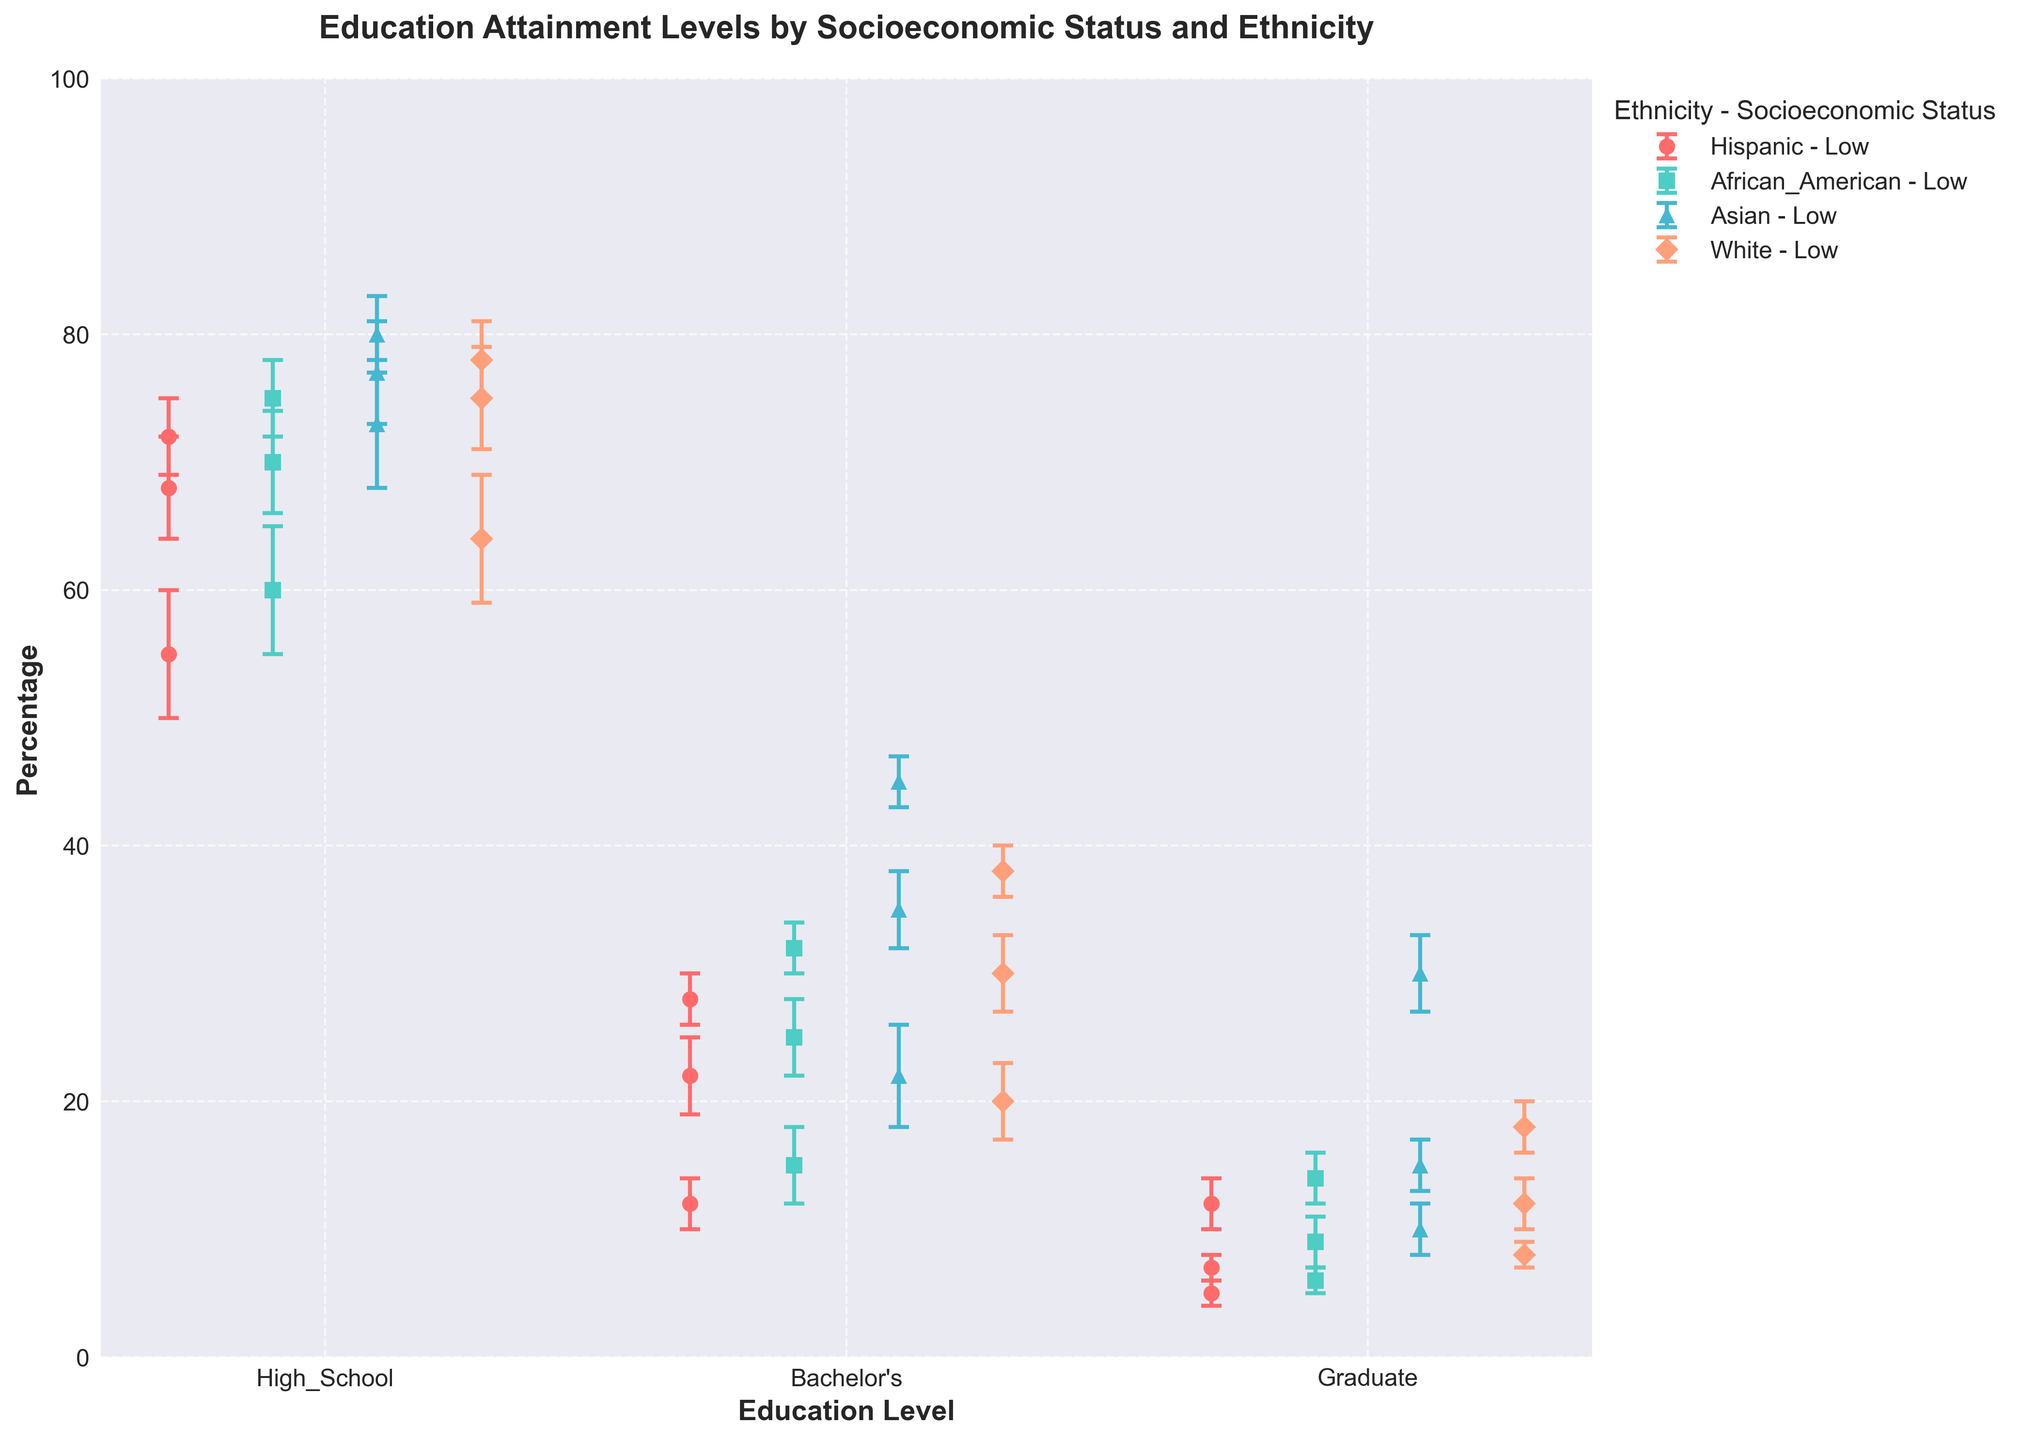What is the title of the figure? The title is always located at the top of the figure. It is typically written in a larger font size and provides a summary of what the plot represents. In this case, it reads "Education Attainment Levels by Socioeconomic Status and Ethnicity."
Answer: Education Attainment Levels by Socioeconomic Status and Ethnicity What does the y-axis represent? The y-axis label provides information about what is being measured. Here, it is labeled "Percentage," indicating that the y-axis represents the percentage of individuals.
Answer: Percentage Which ethnic group has the highest percentage of individuals with a Bachelor's degree in the high socioeconomic status? To find this, look at the markers for Bachelor's degrees under high socioeconomic status for all ethnicities. The highest is the Asian group.
Answer: Asian Compare the error bars for High School attainment in the low socioeconomic status category among all ethnic groups. Which group has the largest error bar? Error bars represent variability or uncertainty. By observing the lengths of the error bars for High School under low socioeconomic status, the Hispanic group has the largest error bar.
Answer: Hispanic What is the mean percentage and error for African Americans with Graduate level education in the middle socioeconomic status? Look closely at the markers representing Graduate level education for African Americans in middle socioeconomic status. The mean percentage is 9%, with an error of 2%.
Answer: 9%, 2% Which ethnic group shows the smallest increase in High School attainment when moving from middle to high socioeconomic status? To determine this, calculate the difference in percentages for High School attainment from middle to high socioeconomic status for each ethnic group and compare. Hispanics go from 68% to 72%, a 4% increase, which is the smallest.
Answer: Hispanic Which ethnic group has the lowest mean percentage of Graduate level education in the high socioeconomic status category? Examine the markers indicating Graduate level education for high socioeconomic status across all ethnic groups. The percentage for Hispanics is the lowest at 12%.
Answer: Hispanic Summarize the trend in Bachelor's level attainment across different socioeconomic statuses for the White ethnic group. Observing the White ethnic group, the mean percentage for Bachelor's degrees increases steadily from low (20%) to middle (30%) to high (38%) socioeconomic status.
Answer: Increases steadily Given the data, which ethnic group shows the highest variability in Bachelor's degree attainment within the low socioeconomic status group? Variability is indicated by the length of error bars. For Bachelor's degree in low socioeconomic status, Asians have an error of 4, which is the highest.
Answer: Asian 